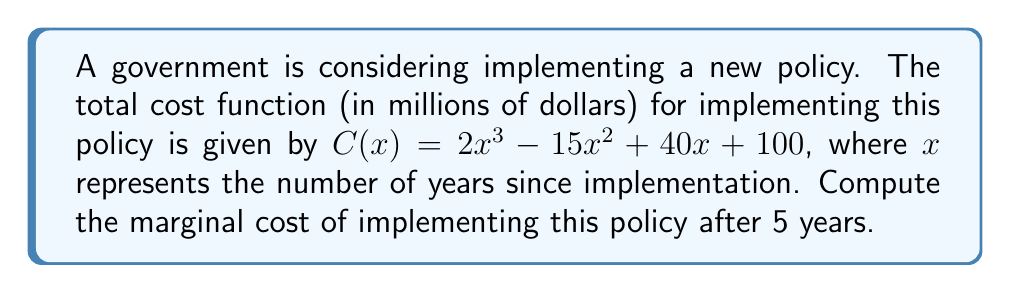Give your solution to this math problem. To find the marginal cost, we need to calculate the derivative of the total cost function and evaluate it at $x = 5$. Let's proceed step-by-step:

1) The total cost function is:
   $C(x) = 2x^3 - 15x^2 + 40x + 100$

2) To find the marginal cost function, we differentiate $C(x)$ with respect to $x$:
   $C'(x) = \frac{d}{dx}(2x^3 - 15x^2 + 40x + 100)$

3) Using the power rule and constant rule of differentiation:
   $C'(x) = 6x^2 - 30x + 40$

4) This $C'(x)$ represents the marginal cost function.

5) To find the marginal cost after 5 years, we evaluate $C'(x)$ at $x = 5$:
   $C'(5) = 6(5)^2 - 30(5) + 40$

6) Simplify:
   $C'(5) = 6(25) - 150 + 40$
   $C'(5) = 150 - 150 + 40$
   $C'(5) = 40$

Therefore, the marginal cost of implementing this policy after 5 years is 40 million dollars per year.
Answer: $40$ million dollars per year 